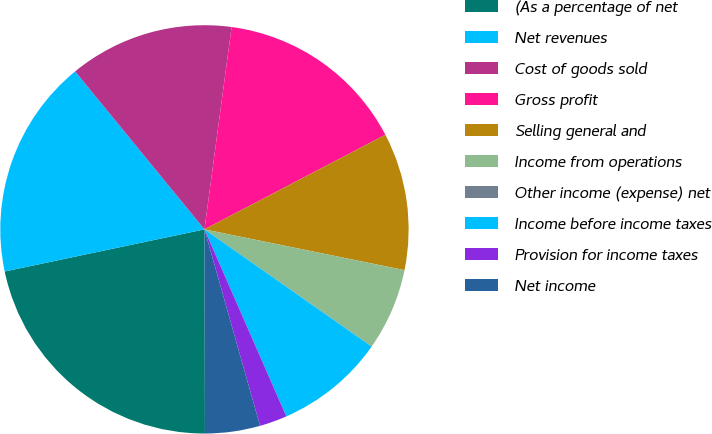Convert chart to OTSL. <chart><loc_0><loc_0><loc_500><loc_500><pie_chart><fcel>(As a percentage of net<fcel>Net revenues<fcel>Cost of goods sold<fcel>Gross profit<fcel>Selling general and<fcel>Income from operations<fcel>Other income (expense) net<fcel>Income before income taxes<fcel>Provision for income taxes<fcel>Net income<nl><fcel>21.73%<fcel>17.39%<fcel>13.04%<fcel>15.21%<fcel>10.87%<fcel>6.52%<fcel>0.01%<fcel>8.7%<fcel>2.18%<fcel>4.35%<nl></chart> 